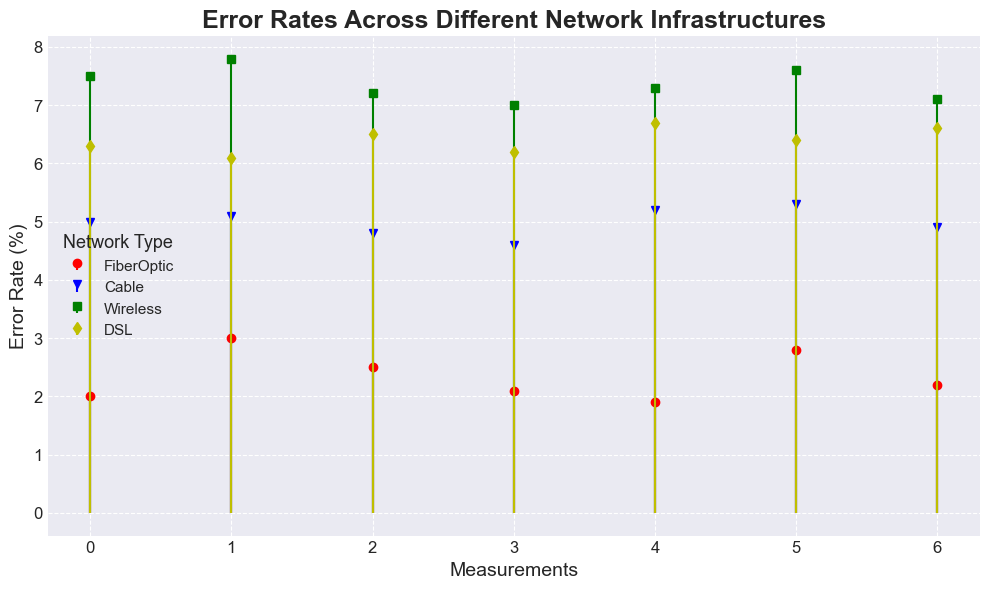What is the average Error Rate for Wireless networks? First, identify the error rates for Wireless networks: 7.5, 7.8, 7.2, 7.0, 7.3, 7.6, 7.1. Sum them up to get 51.5. The number of data points is 7. Divide the sum by the number of data points: 51.5 / 7 = 7.357.
Answer: 7.357 Which network type has the highest average Error Rate? Calculate the average for each network: FiberOptic (2+3+2.5+2.1+1.9+2.8+2.2)/7 = 2.357, Cable (5+5.1+4.8+4.6+5.2+5.3+4.9)/7 = 4.986, Wireless (7.5+7.8+7.2+7+7.3+7.6+7.1)/7 = 7.357, DSL (6.3+6.1+6.5+6.2+6.7+6.4+6.6)/7 = 6.4. Compare the averages and see that Wireless has the highest at 7.357.
Answer: Wireless What is the difference between the highest and lowest Error Rates for Cable network? Identify the highest and lowest error rates for Cable network: highest is 5.3, lowest is 4.6. Subtract the lowest from the highest: 5.3 - 4.6 = 0.7.
Answer: 0.7 Which network has the lowest Error Rate measurement? Find the minimum values for each network: FiberOptic (1.9), Cable (4.6), Wireless (7.0), DSL (6.1). Identify the lowest among these, which is 1.9 for FiberOptic.
Answer: FiberOptic How do the Error Rates for FiberOptic and DSL compare? Calculate the averages for both: FiberOptic = 2.357, DSL = 6.4. Compare the averages: FiberOptic has a much lower error rate than DSL.
Answer: FiberOptic has lower Error Rates than DSL Which network infrastructure shows the most consistency in Error Rates? Consistency can be assessed by the range (difference between highest and lowest value) within each network: FiberOptic (3 - 1.9 = 1.1), Cable (5.3 - 4.6 = 0.7), Wireless (7.8 - 7 = 0.8), DSL (6.7 - 6.1 = 0.6). The DSL network has the smallest range, indicating the most consistency.
Answer: DSL What is the combined average Error Rate of FiberOptic and DSL networks? First, calculate the average for FiberOptic: (2+3+2.5+2.1+1.9+2.8+2.2)/7 = 2.357. Then, calculate the average for DSL: (6.3+6.1+6.5+6.2+6.7+6.4+6.6)/7 = 6.4. Combine their averages: (2.357 + 6.4) / 2 = 4.3785.
Answer: 4.3785 Between Wireless and Cable networks, which one shows more variability in Error Rates? Variability can be assessed by the range within each network: Wireless (7.8 - 7 = 0.8), Cable (5.3 - 4.6 = 0.7). Wireless has a higher range, indicating more variability in error rates.
Answer: Wireless 